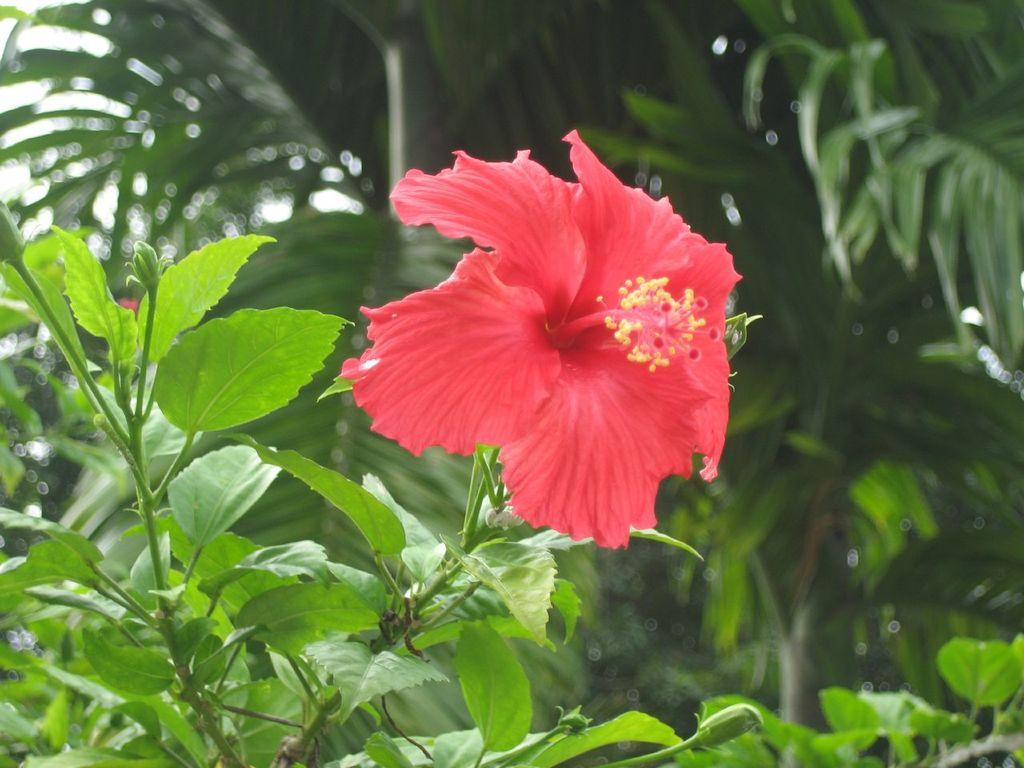What type of plant can be seen in the image? There is a flower in the image. What parts of the plant are visible? There are leaves and stems in the image. How would you describe the background of the image? The background of the image is blurry. What else can be seen in the background of the image? There is a tree visible in the background of the image. What type of crack can be seen in the image? There is no crack present in the image. Who is controlling the flower in the image? The image does not depict anyone controlling the flower; it is a still image of a flower. 